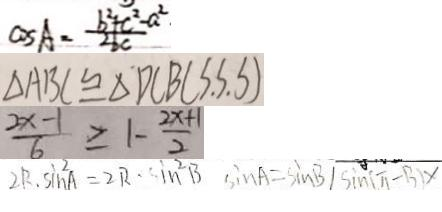<formula> <loc_0><loc_0><loc_500><loc_500>\cos A = \frac { b ^ { 2 } + c ^ { 2 } - a ^ { 2 } \cdot } { 2 b c } 
 \Delta A B C \cong \Delta D C B ( S . S . S ) 
 \frac { 2 x - 1 } { 6 } \geq 1 - \frac { 2 x + 1 } { 2 } 
 2 R . \sin ^ { 2 } A = 2 R . \sin ^ { 2 } B \sin A = \sin B \vert \sin ( \pi - B ) x</formula> 